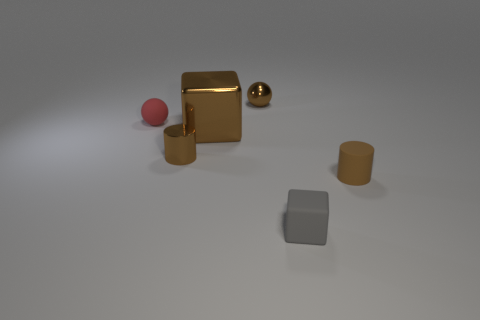Add 3 balls. How many objects exist? 9 Subtract all balls. How many objects are left? 4 Subtract 0 cyan cylinders. How many objects are left? 6 Subtract all matte objects. Subtract all small shiny cylinders. How many objects are left? 2 Add 2 tiny brown cylinders. How many tiny brown cylinders are left? 4 Add 5 metal cubes. How many metal cubes exist? 6 